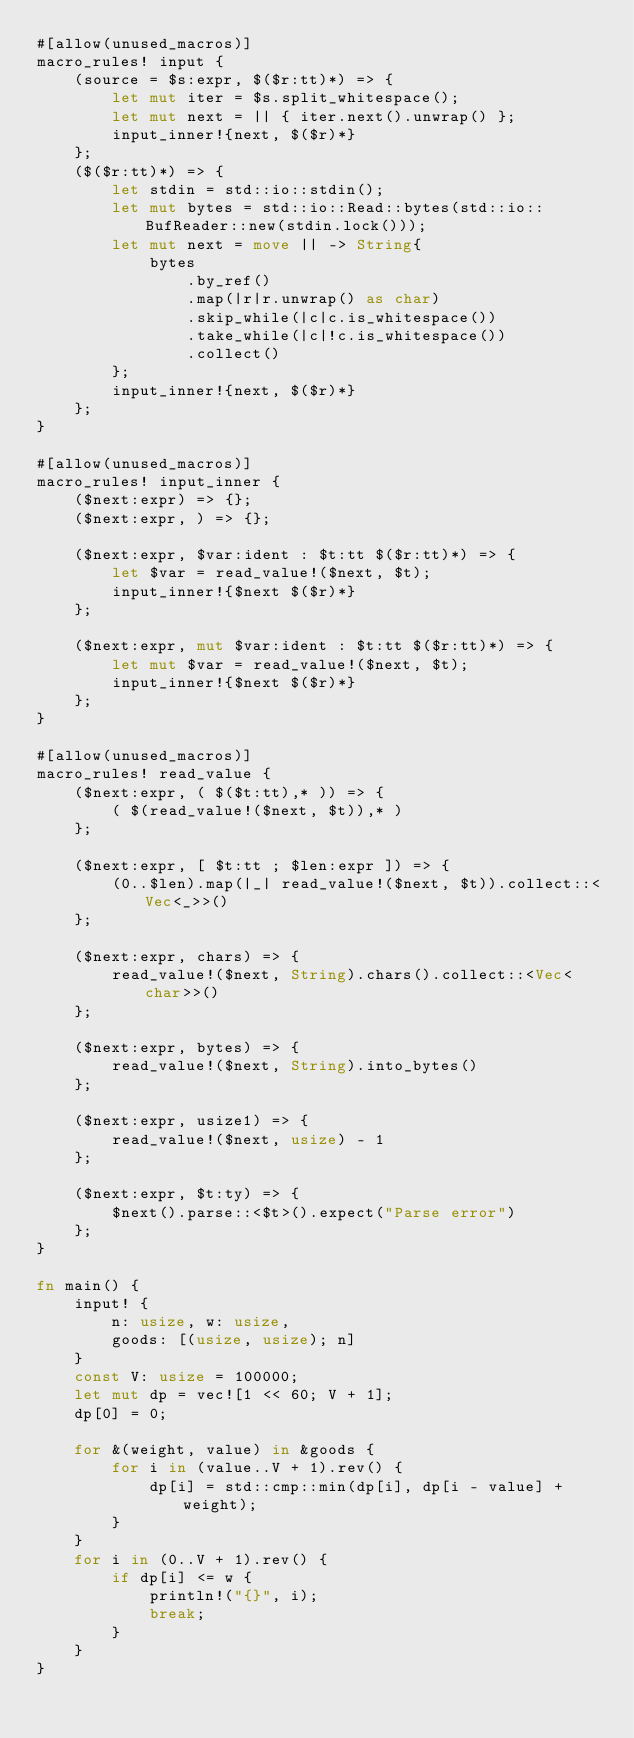Convert code to text. <code><loc_0><loc_0><loc_500><loc_500><_Rust_>#[allow(unused_macros)]
macro_rules! input {
    (source = $s:expr, $($r:tt)*) => {
        let mut iter = $s.split_whitespace();
        let mut next = || { iter.next().unwrap() };
        input_inner!{next, $($r)*}
    };
    ($($r:tt)*) => {
        let stdin = std::io::stdin();
        let mut bytes = std::io::Read::bytes(std::io::BufReader::new(stdin.lock()));
        let mut next = move || -> String{
            bytes
                .by_ref()
                .map(|r|r.unwrap() as char)
                .skip_while(|c|c.is_whitespace())
                .take_while(|c|!c.is_whitespace())
                .collect()
        };
        input_inner!{next, $($r)*}
    };
}

#[allow(unused_macros)]
macro_rules! input_inner {
    ($next:expr) => {};
    ($next:expr, ) => {};

    ($next:expr, $var:ident : $t:tt $($r:tt)*) => {
        let $var = read_value!($next, $t);
        input_inner!{$next $($r)*}
    };

    ($next:expr, mut $var:ident : $t:tt $($r:tt)*) => {
        let mut $var = read_value!($next, $t);
        input_inner!{$next $($r)*}
    };
}

#[allow(unused_macros)]
macro_rules! read_value {
    ($next:expr, ( $($t:tt),* )) => {
        ( $(read_value!($next, $t)),* )
    };

    ($next:expr, [ $t:tt ; $len:expr ]) => {
        (0..$len).map(|_| read_value!($next, $t)).collect::<Vec<_>>()
    };

    ($next:expr, chars) => {
        read_value!($next, String).chars().collect::<Vec<char>>()
    };

    ($next:expr, bytes) => {
        read_value!($next, String).into_bytes()
    };

    ($next:expr, usize1) => {
        read_value!($next, usize) - 1
    };

    ($next:expr, $t:ty) => {
        $next().parse::<$t>().expect("Parse error")
    };
}

fn main() {
    input! {
        n: usize, w: usize,
        goods: [(usize, usize); n]
    }
    const V: usize = 100000;
    let mut dp = vec![1 << 60; V + 1];
    dp[0] = 0;

    for &(weight, value) in &goods {
        for i in (value..V + 1).rev() {
            dp[i] = std::cmp::min(dp[i], dp[i - value] + weight);
        }
    }
    for i in (0..V + 1).rev() {
        if dp[i] <= w {
            println!("{}", i);
            break;
        }
    }
}
</code> 